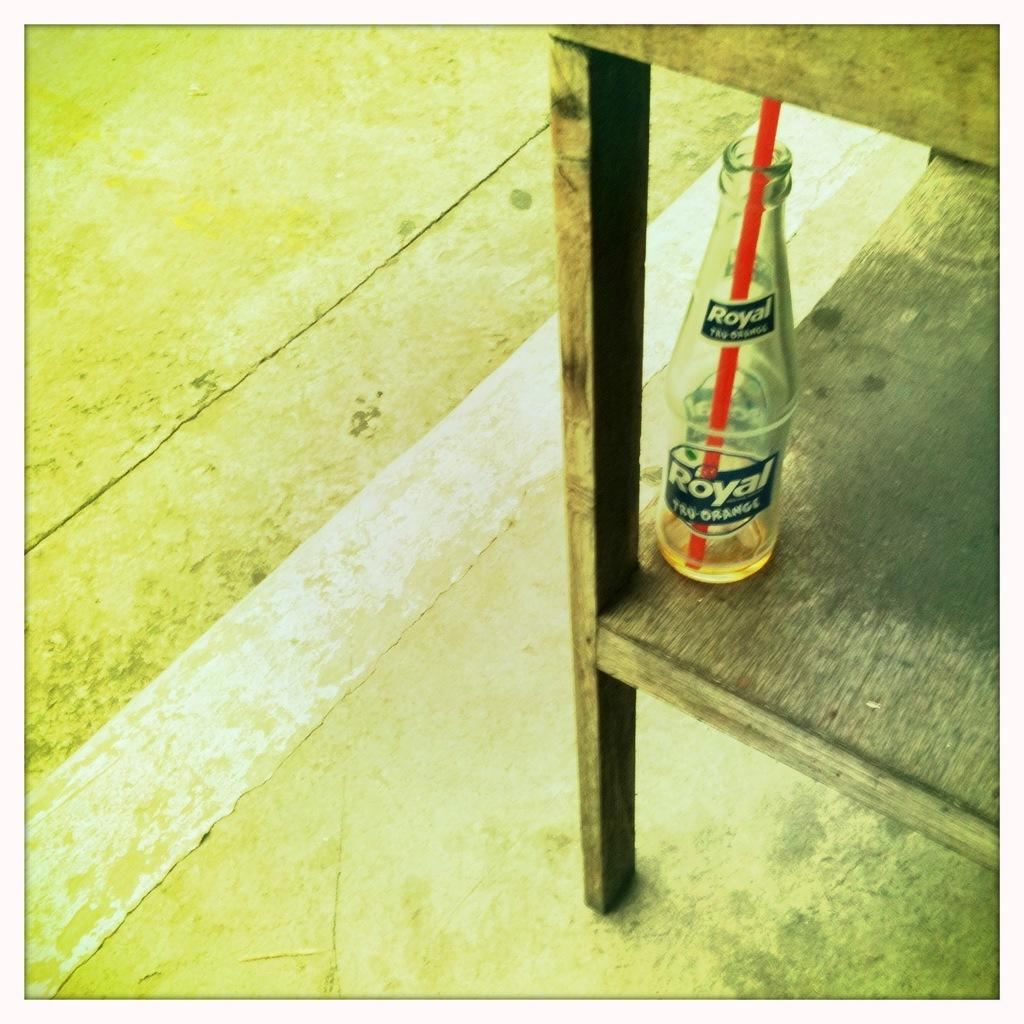<image>
Share a concise interpretation of the image provided. Empty Royal glass can under a table with a red straw. 